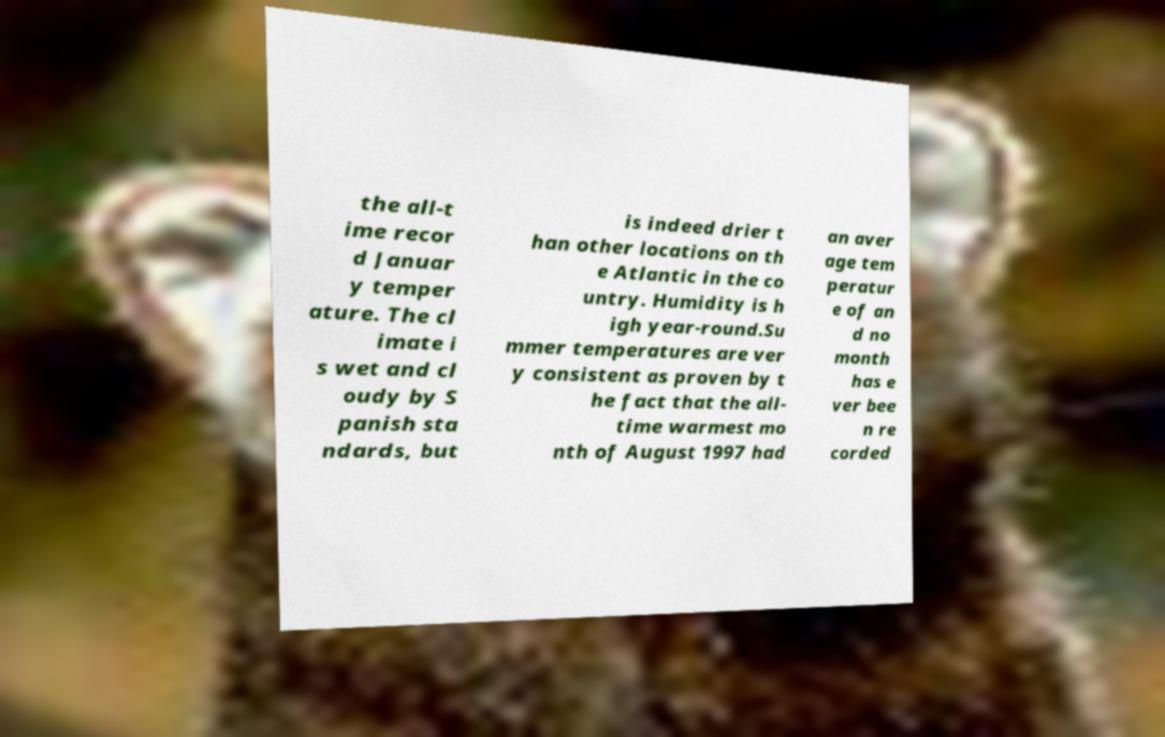I need the written content from this picture converted into text. Can you do that? the all-t ime recor d Januar y temper ature. The cl imate i s wet and cl oudy by S panish sta ndards, but is indeed drier t han other locations on th e Atlantic in the co untry. Humidity is h igh year-round.Su mmer temperatures are ver y consistent as proven by t he fact that the all- time warmest mo nth of August 1997 had an aver age tem peratur e of an d no month has e ver bee n re corded 